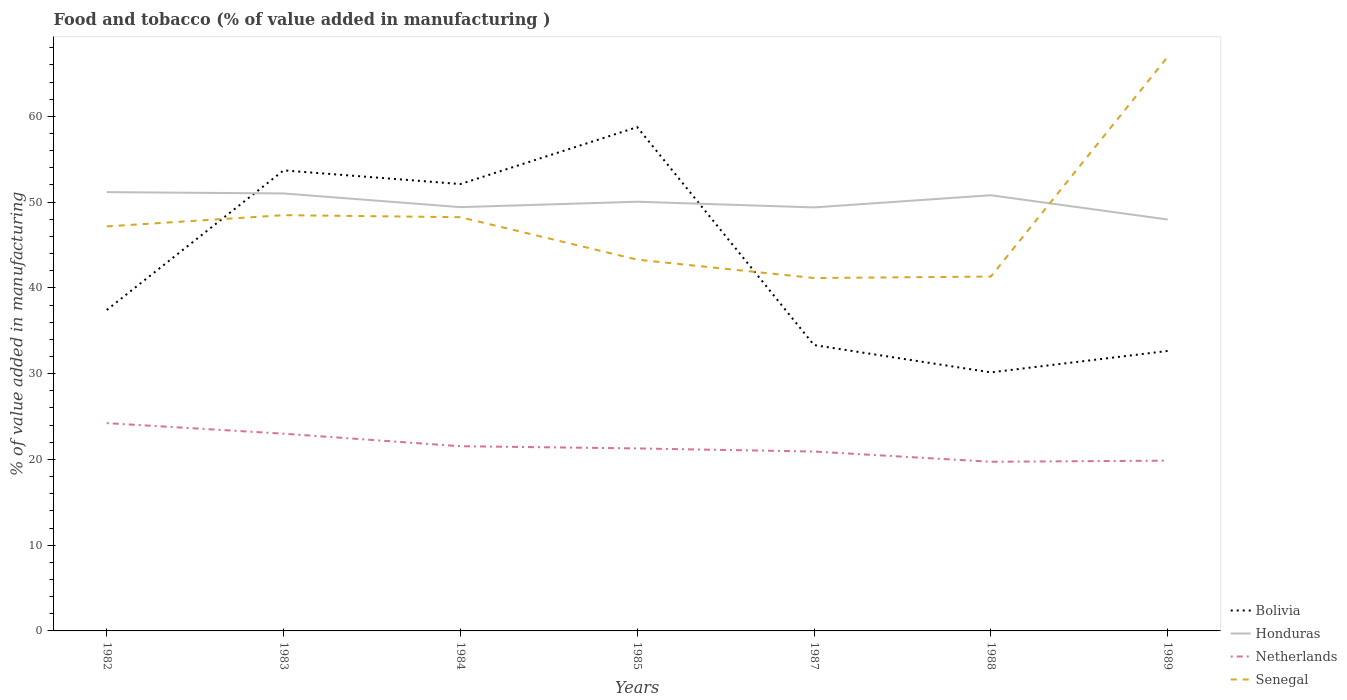How many different coloured lines are there?
Provide a short and direct response. 4. Is the number of lines equal to the number of legend labels?
Your response must be concise. Yes. Across all years, what is the maximum value added in manufacturing food and tobacco in Senegal?
Offer a very short reply. 41.15. In which year was the value added in manufacturing food and tobacco in Honduras maximum?
Your response must be concise. 1989. What is the total value added in manufacturing food and tobacco in Honduras in the graph?
Ensure brevity in your answer.  1.78. What is the difference between the highest and the second highest value added in manufacturing food and tobacco in Honduras?
Your response must be concise. 3.19. What is the difference between the highest and the lowest value added in manufacturing food and tobacco in Senegal?
Ensure brevity in your answer.  3. What is the difference between two consecutive major ticks on the Y-axis?
Your response must be concise. 10. What is the title of the graph?
Your answer should be compact. Food and tobacco (% of value added in manufacturing ). What is the label or title of the Y-axis?
Your response must be concise. % of value added in manufacturing. What is the % of value added in manufacturing in Bolivia in 1982?
Your response must be concise. 37.42. What is the % of value added in manufacturing of Honduras in 1982?
Your answer should be compact. 51.16. What is the % of value added in manufacturing in Netherlands in 1982?
Provide a short and direct response. 24.23. What is the % of value added in manufacturing of Senegal in 1982?
Make the answer very short. 47.17. What is the % of value added in manufacturing in Bolivia in 1983?
Offer a terse response. 53.7. What is the % of value added in manufacturing of Honduras in 1983?
Offer a very short reply. 51.01. What is the % of value added in manufacturing in Netherlands in 1983?
Make the answer very short. 23. What is the % of value added in manufacturing of Senegal in 1983?
Ensure brevity in your answer.  48.48. What is the % of value added in manufacturing of Bolivia in 1984?
Offer a terse response. 52.11. What is the % of value added in manufacturing of Honduras in 1984?
Make the answer very short. 49.41. What is the % of value added in manufacturing in Netherlands in 1984?
Give a very brief answer. 21.54. What is the % of value added in manufacturing of Senegal in 1984?
Your answer should be very brief. 48.24. What is the % of value added in manufacturing of Bolivia in 1985?
Ensure brevity in your answer.  58.75. What is the % of value added in manufacturing in Honduras in 1985?
Ensure brevity in your answer.  50.04. What is the % of value added in manufacturing in Netherlands in 1985?
Your answer should be compact. 21.28. What is the % of value added in manufacturing in Senegal in 1985?
Provide a succinct answer. 43.29. What is the % of value added in manufacturing in Bolivia in 1987?
Give a very brief answer. 33.33. What is the % of value added in manufacturing of Honduras in 1987?
Ensure brevity in your answer.  49.38. What is the % of value added in manufacturing in Netherlands in 1987?
Provide a short and direct response. 20.92. What is the % of value added in manufacturing in Senegal in 1987?
Your answer should be compact. 41.15. What is the % of value added in manufacturing of Bolivia in 1988?
Offer a very short reply. 30.15. What is the % of value added in manufacturing of Honduras in 1988?
Offer a terse response. 50.8. What is the % of value added in manufacturing in Netherlands in 1988?
Provide a short and direct response. 19.72. What is the % of value added in manufacturing in Senegal in 1988?
Provide a succinct answer. 41.32. What is the % of value added in manufacturing of Bolivia in 1989?
Offer a terse response. 32.65. What is the % of value added in manufacturing of Honduras in 1989?
Provide a succinct answer. 47.97. What is the % of value added in manufacturing in Netherlands in 1989?
Offer a very short reply. 19.86. What is the % of value added in manufacturing in Senegal in 1989?
Offer a terse response. 66.94. Across all years, what is the maximum % of value added in manufacturing in Bolivia?
Provide a succinct answer. 58.75. Across all years, what is the maximum % of value added in manufacturing of Honduras?
Your answer should be compact. 51.16. Across all years, what is the maximum % of value added in manufacturing of Netherlands?
Make the answer very short. 24.23. Across all years, what is the maximum % of value added in manufacturing in Senegal?
Your answer should be very brief. 66.94. Across all years, what is the minimum % of value added in manufacturing of Bolivia?
Offer a very short reply. 30.15. Across all years, what is the minimum % of value added in manufacturing in Honduras?
Ensure brevity in your answer.  47.97. Across all years, what is the minimum % of value added in manufacturing in Netherlands?
Provide a short and direct response. 19.72. Across all years, what is the minimum % of value added in manufacturing in Senegal?
Make the answer very short. 41.15. What is the total % of value added in manufacturing of Bolivia in the graph?
Your answer should be very brief. 298.1. What is the total % of value added in manufacturing in Honduras in the graph?
Your answer should be compact. 349.79. What is the total % of value added in manufacturing of Netherlands in the graph?
Your answer should be compact. 150.54. What is the total % of value added in manufacturing of Senegal in the graph?
Ensure brevity in your answer.  336.59. What is the difference between the % of value added in manufacturing of Bolivia in 1982 and that in 1983?
Make the answer very short. -16.28. What is the difference between the % of value added in manufacturing of Honduras in 1982 and that in 1983?
Your answer should be very brief. 0.15. What is the difference between the % of value added in manufacturing of Netherlands in 1982 and that in 1983?
Offer a very short reply. 1.23. What is the difference between the % of value added in manufacturing of Senegal in 1982 and that in 1983?
Your answer should be very brief. -1.31. What is the difference between the % of value added in manufacturing of Bolivia in 1982 and that in 1984?
Your answer should be very brief. -14.69. What is the difference between the % of value added in manufacturing in Honduras in 1982 and that in 1984?
Give a very brief answer. 1.75. What is the difference between the % of value added in manufacturing in Netherlands in 1982 and that in 1984?
Provide a short and direct response. 2.69. What is the difference between the % of value added in manufacturing in Senegal in 1982 and that in 1984?
Provide a succinct answer. -1.07. What is the difference between the % of value added in manufacturing of Bolivia in 1982 and that in 1985?
Offer a terse response. -21.32. What is the difference between the % of value added in manufacturing of Honduras in 1982 and that in 1985?
Your answer should be very brief. 1.12. What is the difference between the % of value added in manufacturing of Netherlands in 1982 and that in 1985?
Your response must be concise. 2.95. What is the difference between the % of value added in manufacturing in Senegal in 1982 and that in 1985?
Keep it short and to the point. 3.88. What is the difference between the % of value added in manufacturing of Bolivia in 1982 and that in 1987?
Make the answer very short. 4.09. What is the difference between the % of value added in manufacturing of Honduras in 1982 and that in 1987?
Ensure brevity in your answer.  1.78. What is the difference between the % of value added in manufacturing of Netherlands in 1982 and that in 1987?
Your response must be concise. 3.31. What is the difference between the % of value added in manufacturing of Senegal in 1982 and that in 1987?
Make the answer very short. 6.02. What is the difference between the % of value added in manufacturing in Bolivia in 1982 and that in 1988?
Offer a terse response. 7.28. What is the difference between the % of value added in manufacturing in Honduras in 1982 and that in 1988?
Your response must be concise. 0.36. What is the difference between the % of value added in manufacturing of Netherlands in 1982 and that in 1988?
Provide a succinct answer. 4.51. What is the difference between the % of value added in manufacturing in Senegal in 1982 and that in 1988?
Offer a very short reply. 5.85. What is the difference between the % of value added in manufacturing in Bolivia in 1982 and that in 1989?
Your answer should be compact. 4.78. What is the difference between the % of value added in manufacturing of Honduras in 1982 and that in 1989?
Your response must be concise. 3.19. What is the difference between the % of value added in manufacturing in Netherlands in 1982 and that in 1989?
Make the answer very short. 4.37. What is the difference between the % of value added in manufacturing of Senegal in 1982 and that in 1989?
Offer a very short reply. -19.77. What is the difference between the % of value added in manufacturing of Bolivia in 1983 and that in 1984?
Your answer should be compact. 1.59. What is the difference between the % of value added in manufacturing in Honduras in 1983 and that in 1984?
Provide a short and direct response. 1.6. What is the difference between the % of value added in manufacturing of Netherlands in 1983 and that in 1984?
Give a very brief answer. 1.46. What is the difference between the % of value added in manufacturing in Senegal in 1983 and that in 1984?
Your answer should be very brief. 0.24. What is the difference between the % of value added in manufacturing of Bolivia in 1983 and that in 1985?
Provide a short and direct response. -5.05. What is the difference between the % of value added in manufacturing in Honduras in 1983 and that in 1985?
Keep it short and to the point. 0.97. What is the difference between the % of value added in manufacturing of Netherlands in 1983 and that in 1985?
Keep it short and to the point. 1.72. What is the difference between the % of value added in manufacturing of Senegal in 1983 and that in 1985?
Offer a terse response. 5.19. What is the difference between the % of value added in manufacturing of Bolivia in 1983 and that in 1987?
Your response must be concise. 20.37. What is the difference between the % of value added in manufacturing in Honduras in 1983 and that in 1987?
Your response must be concise. 1.63. What is the difference between the % of value added in manufacturing of Netherlands in 1983 and that in 1987?
Offer a very short reply. 2.08. What is the difference between the % of value added in manufacturing in Senegal in 1983 and that in 1987?
Make the answer very short. 7.33. What is the difference between the % of value added in manufacturing of Bolivia in 1983 and that in 1988?
Your answer should be very brief. 23.55. What is the difference between the % of value added in manufacturing in Honduras in 1983 and that in 1988?
Make the answer very short. 0.21. What is the difference between the % of value added in manufacturing in Netherlands in 1983 and that in 1988?
Offer a very short reply. 3.27. What is the difference between the % of value added in manufacturing in Senegal in 1983 and that in 1988?
Your response must be concise. 7.16. What is the difference between the % of value added in manufacturing in Bolivia in 1983 and that in 1989?
Make the answer very short. 21.06. What is the difference between the % of value added in manufacturing in Honduras in 1983 and that in 1989?
Your answer should be very brief. 3.04. What is the difference between the % of value added in manufacturing of Netherlands in 1983 and that in 1989?
Offer a very short reply. 3.14. What is the difference between the % of value added in manufacturing in Senegal in 1983 and that in 1989?
Your answer should be very brief. -18.46. What is the difference between the % of value added in manufacturing of Bolivia in 1984 and that in 1985?
Provide a succinct answer. -6.64. What is the difference between the % of value added in manufacturing of Honduras in 1984 and that in 1985?
Keep it short and to the point. -0.63. What is the difference between the % of value added in manufacturing of Netherlands in 1984 and that in 1985?
Your response must be concise. 0.26. What is the difference between the % of value added in manufacturing in Senegal in 1984 and that in 1985?
Your response must be concise. 4.95. What is the difference between the % of value added in manufacturing in Bolivia in 1984 and that in 1987?
Offer a terse response. 18.78. What is the difference between the % of value added in manufacturing in Honduras in 1984 and that in 1987?
Make the answer very short. 0.03. What is the difference between the % of value added in manufacturing in Netherlands in 1984 and that in 1987?
Offer a very short reply. 0.62. What is the difference between the % of value added in manufacturing of Senegal in 1984 and that in 1987?
Provide a succinct answer. 7.09. What is the difference between the % of value added in manufacturing of Bolivia in 1984 and that in 1988?
Ensure brevity in your answer.  21.96. What is the difference between the % of value added in manufacturing in Honduras in 1984 and that in 1988?
Provide a succinct answer. -1.39. What is the difference between the % of value added in manufacturing of Netherlands in 1984 and that in 1988?
Offer a very short reply. 1.81. What is the difference between the % of value added in manufacturing in Senegal in 1984 and that in 1988?
Provide a succinct answer. 6.92. What is the difference between the % of value added in manufacturing of Bolivia in 1984 and that in 1989?
Ensure brevity in your answer.  19.46. What is the difference between the % of value added in manufacturing of Honduras in 1984 and that in 1989?
Offer a terse response. 1.44. What is the difference between the % of value added in manufacturing in Netherlands in 1984 and that in 1989?
Make the answer very short. 1.68. What is the difference between the % of value added in manufacturing in Senegal in 1984 and that in 1989?
Offer a terse response. -18.7. What is the difference between the % of value added in manufacturing in Bolivia in 1985 and that in 1987?
Give a very brief answer. 25.42. What is the difference between the % of value added in manufacturing of Honduras in 1985 and that in 1987?
Provide a succinct answer. 0.66. What is the difference between the % of value added in manufacturing in Netherlands in 1985 and that in 1987?
Offer a very short reply. 0.36. What is the difference between the % of value added in manufacturing in Senegal in 1985 and that in 1987?
Make the answer very short. 2.14. What is the difference between the % of value added in manufacturing in Bolivia in 1985 and that in 1988?
Provide a short and direct response. 28.6. What is the difference between the % of value added in manufacturing of Honduras in 1985 and that in 1988?
Provide a short and direct response. -0.76. What is the difference between the % of value added in manufacturing of Netherlands in 1985 and that in 1988?
Make the answer very short. 1.56. What is the difference between the % of value added in manufacturing in Senegal in 1985 and that in 1988?
Your answer should be very brief. 1.97. What is the difference between the % of value added in manufacturing in Bolivia in 1985 and that in 1989?
Your answer should be very brief. 26.1. What is the difference between the % of value added in manufacturing in Honduras in 1985 and that in 1989?
Offer a very short reply. 2.07. What is the difference between the % of value added in manufacturing in Netherlands in 1985 and that in 1989?
Keep it short and to the point. 1.42. What is the difference between the % of value added in manufacturing in Senegal in 1985 and that in 1989?
Provide a short and direct response. -23.65. What is the difference between the % of value added in manufacturing of Bolivia in 1987 and that in 1988?
Make the answer very short. 3.18. What is the difference between the % of value added in manufacturing in Honduras in 1987 and that in 1988?
Make the answer very short. -1.42. What is the difference between the % of value added in manufacturing of Netherlands in 1987 and that in 1988?
Provide a short and direct response. 1.19. What is the difference between the % of value added in manufacturing of Senegal in 1987 and that in 1988?
Keep it short and to the point. -0.17. What is the difference between the % of value added in manufacturing of Bolivia in 1987 and that in 1989?
Your answer should be compact. 0.68. What is the difference between the % of value added in manufacturing of Honduras in 1987 and that in 1989?
Your response must be concise. 1.41. What is the difference between the % of value added in manufacturing of Netherlands in 1987 and that in 1989?
Give a very brief answer. 1.06. What is the difference between the % of value added in manufacturing of Senegal in 1987 and that in 1989?
Give a very brief answer. -25.79. What is the difference between the % of value added in manufacturing of Bolivia in 1988 and that in 1989?
Your answer should be very brief. -2.5. What is the difference between the % of value added in manufacturing of Honduras in 1988 and that in 1989?
Make the answer very short. 2.83. What is the difference between the % of value added in manufacturing in Netherlands in 1988 and that in 1989?
Ensure brevity in your answer.  -0.13. What is the difference between the % of value added in manufacturing in Senegal in 1988 and that in 1989?
Make the answer very short. -25.62. What is the difference between the % of value added in manufacturing in Bolivia in 1982 and the % of value added in manufacturing in Honduras in 1983?
Provide a succinct answer. -13.59. What is the difference between the % of value added in manufacturing in Bolivia in 1982 and the % of value added in manufacturing in Netherlands in 1983?
Keep it short and to the point. 14.42. What is the difference between the % of value added in manufacturing of Bolivia in 1982 and the % of value added in manufacturing of Senegal in 1983?
Your response must be concise. -11.06. What is the difference between the % of value added in manufacturing in Honduras in 1982 and the % of value added in manufacturing in Netherlands in 1983?
Provide a succinct answer. 28.17. What is the difference between the % of value added in manufacturing in Honduras in 1982 and the % of value added in manufacturing in Senegal in 1983?
Your answer should be very brief. 2.69. What is the difference between the % of value added in manufacturing of Netherlands in 1982 and the % of value added in manufacturing of Senegal in 1983?
Your answer should be compact. -24.25. What is the difference between the % of value added in manufacturing in Bolivia in 1982 and the % of value added in manufacturing in Honduras in 1984?
Provide a short and direct response. -11.99. What is the difference between the % of value added in manufacturing in Bolivia in 1982 and the % of value added in manufacturing in Netherlands in 1984?
Offer a terse response. 15.88. What is the difference between the % of value added in manufacturing in Bolivia in 1982 and the % of value added in manufacturing in Senegal in 1984?
Offer a terse response. -10.82. What is the difference between the % of value added in manufacturing in Honduras in 1982 and the % of value added in manufacturing in Netherlands in 1984?
Provide a short and direct response. 29.63. What is the difference between the % of value added in manufacturing of Honduras in 1982 and the % of value added in manufacturing of Senegal in 1984?
Your answer should be very brief. 2.92. What is the difference between the % of value added in manufacturing in Netherlands in 1982 and the % of value added in manufacturing in Senegal in 1984?
Give a very brief answer. -24.01. What is the difference between the % of value added in manufacturing of Bolivia in 1982 and the % of value added in manufacturing of Honduras in 1985?
Your answer should be compact. -12.62. What is the difference between the % of value added in manufacturing of Bolivia in 1982 and the % of value added in manufacturing of Netherlands in 1985?
Your response must be concise. 16.14. What is the difference between the % of value added in manufacturing in Bolivia in 1982 and the % of value added in manufacturing in Senegal in 1985?
Your answer should be compact. -5.87. What is the difference between the % of value added in manufacturing in Honduras in 1982 and the % of value added in manufacturing in Netherlands in 1985?
Keep it short and to the point. 29.88. What is the difference between the % of value added in manufacturing in Honduras in 1982 and the % of value added in manufacturing in Senegal in 1985?
Keep it short and to the point. 7.87. What is the difference between the % of value added in manufacturing of Netherlands in 1982 and the % of value added in manufacturing of Senegal in 1985?
Offer a very short reply. -19.06. What is the difference between the % of value added in manufacturing in Bolivia in 1982 and the % of value added in manufacturing in Honduras in 1987?
Your answer should be very brief. -11.96. What is the difference between the % of value added in manufacturing of Bolivia in 1982 and the % of value added in manufacturing of Netherlands in 1987?
Keep it short and to the point. 16.5. What is the difference between the % of value added in manufacturing of Bolivia in 1982 and the % of value added in manufacturing of Senegal in 1987?
Provide a succinct answer. -3.73. What is the difference between the % of value added in manufacturing of Honduras in 1982 and the % of value added in manufacturing of Netherlands in 1987?
Your response must be concise. 30.25. What is the difference between the % of value added in manufacturing in Honduras in 1982 and the % of value added in manufacturing in Senegal in 1987?
Keep it short and to the point. 10.02. What is the difference between the % of value added in manufacturing in Netherlands in 1982 and the % of value added in manufacturing in Senegal in 1987?
Keep it short and to the point. -16.92. What is the difference between the % of value added in manufacturing in Bolivia in 1982 and the % of value added in manufacturing in Honduras in 1988?
Offer a terse response. -13.38. What is the difference between the % of value added in manufacturing in Bolivia in 1982 and the % of value added in manufacturing in Netherlands in 1988?
Provide a short and direct response. 17.7. What is the difference between the % of value added in manufacturing in Bolivia in 1982 and the % of value added in manufacturing in Senegal in 1988?
Your answer should be very brief. -3.9. What is the difference between the % of value added in manufacturing of Honduras in 1982 and the % of value added in manufacturing of Netherlands in 1988?
Ensure brevity in your answer.  31.44. What is the difference between the % of value added in manufacturing in Honduras in 1982 and the % of value added in manufacturing in Senegal in 1988?
Ensure brevity in your answer.  9.84. What is the difference between the % of value added in manufacturing of Netherlands in 1982 and the % of value added in manufacturing of Senegal in 1988?
Provide a short and direct response. -17.09. What is the difference between the % of value added in manufacturing in Bolivia in 1982 and the % of value added in manufacturing in Honduras in 1989?
Provide a short and direct response. -10.55. What is the difference between the % of value added in manufacturing of Bolivia in 1982 and the % of value added in manufacturing of Netherlands in 1989?
Offer a terse response. 17.57. What is the difference between the % of value added in manufacturing in Bolivia in 1982 and the % of value added in manufacturing in Senegal in 1989?
Keep it short and to the point. -29.52. What is the difference between the % of value added in manufacturing in Honduras in 1982 and the % of value added in manufacturing in Netherlands in 1989?
Your answer should be compact. 31.31. What is the difference between the % of value added in manufacturing of Honduras in 1982 and the % of value added in manufacturing of Senegal in 1989?
Ensure brevity in your answer.  -15.78. What is the difference between the % of value added in manufacturing in Netherlands in 1982 and the % of value added in manufacturing in Senegal in 1989?
Ensure brevity in your answer.  -42.71. What is the difference between the % of value added in manufacturing in Bolivia in 1983 and the % of value added in manufacturing in Honduras in 1984?
Offer a terse response. 4.29. What is the difference between the % of value added in manufacturing in Bolivia in 1983 and the % of value added in manufacturing in Netherlands in 1984?
Provide a short and direct response. 32.16. What is the difference between the % of value added in manufacturing of Bolivia in 1983 and the % of value added in manufacturing of Senegal in 1984?
Keep it short and to the point. 5.46. What is the difference between the % of value added in manufacturing in Honduras in 1983 and the % of value added in manufacturing in Netherlands in 1984?
Keep it short and to the point. 29.47. What is the difference between the % of value added in manufacturing in Honduras in 1983 and the % of value added in manufacturing in Senegal in 1984?
Your answer should be very brief. 2.77. What is the difference between the % of value added in manufacturing in Netherlands in 1983 and the % of value added in manufacturing in Senegal in 1984?
Offer a terse response. -25.24. What is the difference between the % of value added in manufacturing of Bolivia in 1983 and the % of value added in manufacturing of Honduras in 1985?
Your answer should be compact. 3.66. What is the difference between the % of value added in manufacturing of Bolivia in 1983 and the % of value added in manufacturing of Netherlands in 1985?
Offer a terse response. 32.42. What is the difference between the % of value added in manufacturing in Bolivia in 1983 and the % of value added in manufacturing in Senegal in 1985?
Provide a succinct answer. 10.41. What is the difference between the % of value added in manufacturing of Honduras in 1983 and the % of value added in manufacturing of Netherlands in 1985?
Make the answer very short. 29.73. What is the difference between the % of value added in manufacturing of Honduras in 1983 and the % of value added in manufacturing of Senegal in 1985?
Your answer should be very brief. 7.72. What is the difference between the % of value added in manufacturing of Netherlands in 1983 and the % of value added in manufacturing of Senegal in 1985?
Provide a short and direct response. -20.29. What is the difference between the % of value added in manufacturing of Bolivia in 1983 and the % of value added in manufacturing of Honduras in 1987?
Your answer should be very brief. 4.32. What is the difference between the % of value added in manufacturing of Bolivia in 1983 and the % of value added in manufacturing of Netherlands in 1987?
Provide a short and direct response. 32.78. What is the difference between the % of value added in manufacturing of Bolivia in 1983 and the % of value added in manufacturing of Senegal in 1987?
Keep it short and to the point. 12.55. What is the difference between the % of value added in manufacturing in Honduras in 1983 and the % of value added in manufacturing in Netherlands in 1987?
Ensure brevity in your answer.  30.09. What is the difference between the % of value added in manufacturing in Honduras in 1983 and the % of value added in manufacturing in Senegal in 1987?
Your answer should be compact. 9.86. What is the difference between the % of value added in manufacturing of Netherlands in 1983 and the % of value added in manufacturing of Senegal in 1987?
Your answer should be very brief. -18.15. What is the difference between the % of value added in manufacturing of Bolivia in 1983 and the % of value added in manufacturing of Honduras in 1988?
Your answer should be very brief. 2.9. What is the difference between the % of value added in manufacturing of Bolivia in 1983 and the % of value added in manufacturing of Netherlands in 1988?
Make the answer very short. 33.98. What is the difference between the % of value added in manufacturing of Bolivia in 1983 and the % of value added in manufacturing of Senegal in 1988?
Keep it short and to the point. 12.38. What is the difference between the % of value added in manufacturing of Honduras in 1983 and the % of value added in manufacturing of Netherlands in 1988?
Give a very brief answer. 31.29. What is the difference between the % of value added in manufacturing of Honduras in 1983 and the % of value added in manufacturing of Senegal in 1988?
Your answer should be very brief. 9.69. What is the difference between the % of value added in manufacturing of Netherlands in 1983 and the % of value added in manufacturing of Senegal in 1988?
Your answer should be very brief. -18.32. What is the difference between the % of value added in manufacturing in Bolivia in 1983 and the % of value added in manufacturing in Honduras in 1989?
Ensure brevity in your answer.  5.73. What is the difference between the % of value added in manufacturing of Bolivia in 1983 and the % of value added in manufacturing of Netherlands in 1989?
Offer a very short reply. 33.85. What is the difference between the % of value added in manufacturing in Bolivia in 1983 and the % of value added in manufacturing in Senegal in 1989?
Ensure brevity in your answer.  -13.24. What is the difference between the % of value added in manufacturing in Honduras in 1983 and the % of value added in manufacturing in Netherlands in 1989?
Offer a very short reply. 31.16. What is the difference between the % of value added in manufacturing in Honduras in 1983 and the % of value added in manufacturing in Senegal in 1989?
Offer a terse response. -15.93. What is the difference between the % of value added in manufacturing in Netherlands in 1983 and the % of value added in manufacturing in Senegal in 1989?
Ensure brevity in your answer.  -43.94. What is the difference between the % of value added in manufacturing of Bolivia in 1984 and the % of value added in manufacturing of Honduras in 1985?
Give a very brief answer. 2.06. What is the difference between the % of value added in manufacturing in Bolivia in 1984 and the % of value added in manufacturing in Netherlands in 1985?
Your answer should be compact. 30.83. What is the difference between the % of value added in manufacturing in Bolivia in 1984 and the % of value added in manufacturing in Senegal in 1985?
Provide a short and direct response. 8.82. What is the difference between the % of value added in manufacturing of Honduras in 1984 and the % of value added in manufacturing of Netherlands in 1985?
Provide a succinct answer. 28.13. What is the difference between the % of value added in manufacturing of Honduras in 1984 and the % of value added in manufacturing of Senegal in 1985?
Give a very brief answer. 6.12. What is the difference between the % of value added in manufacturing in Netherlands in 1984 and the % of value added in manufacturing in Senegal in 1985?
Provide a short and direct response. -21.75. What is the difference between the % of value added in manufacturing in Bolivia in 1984 and the % of value added in manufacturing in Honduras in 1987?
Ensure brevity in your answer.  2.72. What is the difference between the % of value added in manufacturing in Bolivia in 1984 and the % of value added in manufacturing in Netherlands in 1987?
Give a very brief answer. 31.19. What is the difference between the % of value added in manufacturing of Bolivia in 1984 and the % of value added in manufacturing of Senegal in 1987?
Your response must be concise. 10.96. What is the difference between the % of value added in manufacturing of Honduras in 1984 and the % of value added in manufacturing of Netherlands in 1987?
Your answer should be compact. 28.5. What is the difference between the % of value added in manufacturing of Honduras in 1984 and the % of value added in manufacturing of Senegal in 1987?
Your answer should be compact. 8.26. What is the difference between the % of value added in manufacturing in Netherlands in 1984 and the % of value added in manufacturing in Senegal in 1987?
Give a very brief answer. -19.61. What is the difference between the % of value added in manufacturing in Bolivia in 1984 and the % of value added in manufacturing in Honduras in 1988?
Make the answer very short. 1.31. What is the difference between the % of value added in manufacturing in Bolivia in 1984 and the % of value added in manufacturing in Netherlands in 1988?
Your response must be concise. 32.38. What is the difference between the % of value added in manufacturing of Bolivia in 1984 and the % of value added in manufacturing of Senegal in 1988?
Offer a very short reply. 10.79. What is the difference between the % of value added in manufacturing of Honduras in 1984 and the % of value added in manufacturing of Netherlands in 1988?
Your response must be concise. 29.69. What is the difference between the % of value added in manufacturing of Honduras in 1984 and the % of value added in manufacturing of Senegal in 1988?
Offer a terse response. 8.09. What is the difference between the % of value added in manufacturing of Netherlands in 1984 and the % of value added in manufacturing of Senegal in 1988?
Give a very brief answer. -19.78. What is the difference between the % of value added in manufacturing of Bolivia in 1984 and the % of value added in manufacturing of Honduras in 1989?
Give a very brief answer. 4.14. What is the difference between the % of value added in manufacturing in Bolivia in 1984 and the % of value added in manufacturing in Netherlands in 1989?
Provide a short and direct response. 32.25. What is the difference between the % of value added in manufacturing in Bolivia in 1984 and the % of value added in manufacturing in Senegal in 1989?
Provide a short and direct response. -14.83. What is the difference between the % of value added in manufacturing of Honduras in 1984 and the % of value added in manufacturing of Netherlands in 1989?
Your response must be concise. 29.56. What is the difference between the % of value added in manufacturing in Honduras in 1984 and the % of value added in manufacturing in Senegal in 1989?
Provide a succinct answer. -17.53. What is the difference between the % of value added in manufacturing of Netherlands in 1984 and the % of value added in manufacturing of Senegal in 1989?
Keep it short and to the point. -45.4. What is the difference between the % of value added in manufacturing in Bolivia in 1985 and the % of value added in manufacturing in Honduras in 1987?
Offer a terse response. 9.36. What is the difference between the % of value added in manufacturing in Bolivia in 1985 and the % of value added in manufacturing in Netherlands in 1987?
Provide a short and direct response. 37.83. What is the difference between the % of value added in manufacturing in Bolivia in 1985 and the % of value added in manufacturing in Senegal in 1987?
Provide a succinct answer. 17.6. What is the difference between the % of value added in manufacturing in Honduras in 1985 and the % of value added in manufacturing in Netherlands in 1987?
Provide a short and direct response. 29.13. What is the difference between the % of value added in manufacturing of Honduras in 1985 and the % of value added in manufacturing of Senegal in 1987?
Ensure brevity in your answer.  8.9. What is the difference between the % of value added in manufacturing of Netherlands in 1985 and the % of value added in manufacturing of Senegal in 1987?
Give a very brief answer. -19.87. What is the difference between the % of value added in manufacturing in Bolivia in 1985 and the % of value added in manufacturing in Honduras in 1988?
Offer a very short reply. 7.94. What is the difference between the % of value added in manufacturing in Bolivia in 1985 and the % of value added in manufacturing in Netherlands in 1988?
Your response must be concise. 39.02. What is the difference between the % of value added in manufacturing of Bolivia in 1985 and the % of value added in manufacturing of Senegal in 1988?
Your answer should be compact. 17.43. What is the difference between the % of value added in manufacturing of Honduras in 1985 and the % of value added in manufacturing of Netherlands in 1988?
Ensure brevity in your answer.  30.32. What is the difference between the % of value added in manufacturing in Honduras in 1985 and the % of value added in manufacturing in Senegal in 1988?
Provide a succinct answer. 8.72. What is the difference between the % of value added in manufacturing of Netherlands in 1985 and the % of value added in manufacturing of Senegal in 1988?
Your answer should be very brief. -20.04. What is the difference between the % of value added in manufacturing in Bolivia in 1985 and the % of value added in manufacturing in Honduras in 1989?
Make the answer very short. 10.77. What is the difference between the % of value added in manufacturing in Bolivia in 1985 and the % of value added in manufacturing in Netherlands in 1989?
Keep it short and to the point. 38.89. What is the difference between the % of value added in manufacturing in Bolivia in 1985 and the % of value added in manufacturing in Senegal in 1989?
Your response must be concise. -8.2. What is the difference between the % of value added in manufacturing in Honduras in 1985 and the % of value added in manufacturing in Netherlands in 1989?
Offer a terse response. 30.19. What is the difference between the % of value added in manufacturing of Honduras in 1985 and the % of value added in manufacturing of Senegal in 1989?
Your answer should be compact. -16.9. What is the difference between the % of value added in manufacturing of Netherlands in 1985 and the % of value added in manufacturing of Senegal in 1989?
Offer a terse response. -45.66. What is the difference between the % of value added in manufacturing in Bolivia in 1987 and the % of value added in manufacturing in Honduras in 1988?
Offer a very short reply. -17.47. What is the difference between the % of value added in manufacturing in Bolivia in 1987 and the % of value added in manufacturing in Netherlands in 1988?
Offer a very short reply. 13.61. What is the difference between the % of value added in manufacturing of Bolivia in 1987 and the % of value added in manufacturing of Senegal in 1988?
Offer a terse response. -7.99. What is the difference between the % of value added in manufacturing in Honduras in 1987 and the % of value added in manufacturing in Netherlands in 1988?
Ensure brevity in your answer.  29.66. What is the difference between the % of value added in manufacturing of Honduras in 1987 and the % of value added in manufacturing of Senegal in 1988?
Make the answer very short. 8.06. What is the difference between the % of value added in manufacturing of Netherlands in 1987 and the % of value added in manufacturing of Senegal in 1988?
Your answer should be very brief. -20.4. What is the difference between the % of value added in manufacturing in Bolivia in 1987 and the % of value added in manufacturing in Honduras in 1989?
Provide a succinct answer. -14.64. What is the difference between the % of value added in manufacturing in Bolivia in 1987 and the % of value added in manufacturing in Netherlands in 1989?
Your answer should be compact. 13.47. What is the difference between the % of value added in manufacturing of Bolivia in 1987 and the % of value added in manufacturing of Senegal in 1989?
Provide a short and direct response. -33.61. What is the difference between the % of value added in manufacturing in Honduras in 1987 and the % of value added in manufacturing in Netherlands in 1989?
Provide a short and direct response. 29.53. What is the difference between the % of value added in manufacturing in Honduras in 1987 and the % of value added in manufacturing in Senegal in 1989?
Provide a succinct answer. -17.56. What is the difference between the % of value added in manufacturing of Netherlands in 1987 and the % of value added in manufacturing of Senegal in 1989?
Give a very brief answer. -46.02. What is the difference between the % of value added in manufacturing of Bolivia in 1988 and the % of value added in manufacturing of Honduras in 1989?
Keep it short and to the point. -17.83. What is the difference between the % of value added in manufacturing of Bolivia in 1988 and the % of value added in manufacturing of Netherlands in 1989?
Your answer should be very brief. 10.29. What is the difference between the % of value added in manufacturing in Bolivia in 1988 and the % of value added in manufacturing in Senegal in 1989?
Provide a succinct answer. -36.8. What is the difference between the % of value added in manufacturing in Honduras in 1988 and the % of value added in manufacturing in Netherlands in 1989?
Your answer should be compact. 30.95. What is the difference between the % of value added in manufacturing of Honduras in 1988 and the % of value added in manufacturing of Senegal in 1989?
Keep it short and to the point. -16.14. What is the difference between the % of value added in manufacturing in Netherlands in 1988 and the % of value added in manufacturing in Senegal in 1989?
Offer a very short reply. -47.22. What is the average % of value added in manufacturing in Bolivia per year?
Provide a succinct answer. 42.59. What is the average % of value added in manufacturing of Honduras per year?
Your response must be concise. 49.97. What is the average % of value added in manufacturing in Netherlands per year?
Ensure brevity in your answer.  21.51. What is the average % of value added in manufacturing in Senegal per year?
Provide a succinct answer. 48.08. In the year 1982, what is the difference between the % of value added in manufacturing in Bolivia and % of value added in manufacturing in Honduras?
Make the answer very short. -13.74. In the year 1982, what is the difference between the % of value added in manufacturing in Bolivia and % of value added in manufacturing in Netherlands?
Offer a terse response. 13.19. In the year 1982, what is the difference between the % of value added in manufacturing in Bolivia and % of value added in manufacturing in Senegal?
Your response must be concise. -9.75. In the year 1982, what is the difference between the % of value added in manufacturing of Honduras and % of value added in manufacturing of Netherlands?
Offer a terse response. 26.93. In the year 1982, what is the difference between the % of value added in manufacturing of Honduras and % of value added in manufacturing of Senegal?
Your response must be concise. 4. In the year 1982, what is the difference between the % of value added in manufacturing of Netherlands and % of value added in manufacturing of Senegal?
Provide a short and direct response. -22.94. In the year 1983, what is the difference between the % of value added in manufacturing in Bolivia and % of value added in manufacturing in Honduras?
Your answer should be compact. 2.69. In the year 1983, what is the difference between the % of value added in manufacturing in Bolivia and % of value added in manufacturing in Netherlands?
Your response must be concise. 30.7. In the year 1983, what is the difference between the % of value added in manufacturing of Bolivia and % of value added in manufacturing of Senegal?
Offer a terse response. 5.22. In the year 1983, what is the difference between the % of value added in manufacturing in Honduras and % of value added in manufacturing in Netherlands?
Provide a short and direct response. 28.01. In the year 1983, what is the difference between the % of value added in manufacturing of Honduras and % of value added in manufacturing of Senegal?
Offer a terse response. 2.53. In the year 1983, what is the difference between the % of value added in manufacturing of Netherlands and % of value added in manufacturing of Senegal?
Your response must be concise. -25.48. In the year 1984, what is the difference between the % of value added in manufacturing in Bolivia and % of value added in manufacturing in Honduras?
Give a very brief answer. 2.69. In the year 1984, what is the difference between the % of value added in manufacturing of Bolivia and % of value added in manufacturing of Netherlands?
Make the answer very short. 30.57. In the year 1984, what is the difference between the % of value added in manufacturing of Bolivia and % of value added in manufacturing of Senegal?
Your answer should be compact. 3.87. In the year 1984, what is the difference between the % of value added in manufacturing of Honduras and % of value added in manufacturing of Netherlands?
Give a very brief answer. 27.88. In the year 1984, what is the difference between the % of value added in manufacturing in Honduras and % of value added in manufacturing in Senegal?
Provide a succinct answer. 1.17. In the year 1984, what is the difference between the % of value added in manufacturing in Netherlands and % of value added in manufacturing in Senegal?
Your response must be concise. -26.7. In the year 1985, what is the difference between the % of value added in manufacturing of Bolivia and % of value added in manufacturing of Honduras?
Your response must be concise. 8.7. In the year 1985, what is the difference between the % of value added in manufacturing of Bolivia and % of value added in manufacturing of Netherlands?
Offer a very short reply. 37.47. In the year 1985, what is the difference between the % of value added in manufacturing in Bolivia and % of value added in manufacturing in Senegal?
Offer a very short reply. 15.45. In the year 1985, what is the difference between the % of value added in manufacturing in Honduras and % of value added in manufacturing in Netherlands?
Your answer should be very brief. 28.76. In the year 1985, what is the difference between the % of value added in manufacturing in Honduras and % of value added in manufacturing in Senegal?
Your response must be concise. 6.75. In the year 1985, what is the difference between the % of value added in manufacturing in Netherlands and % of value added in manufacturing in Senegal?
Keep it short and to the point. -22.01. In the year 1987, what is the difference between the % of value added in manufacturing in Bolivia and % of value added in manufacturing in Honduras?
Offer a very short reply. -16.05. In the year 1987, what is the difference between the % of value added in manufacturing of Bolivia and % of value added in manufacturing of Netherlands?
Provide a succinct answer. 12.41. In the year 1987, what is the difference between the % of value added in manufacturing in Bolivia and % of value added in manufacturing in Senegal?
Ensure brevity in your answer.  -7.82. In the year 1987, what is the difference between the % of value added in manufacturing in Honduras and % of value added in manufacturing in Netherlands?
Offer a terse response. 28.47. In the year 1987, what is the difference between the % of value added in manufacturing in Honduras and % of value added in manufacturing in Senegal?
Provide a succinct answer. 8.23. In the year 1987, what is the difference between the % of value added in manufacturing of Netherlands and % of value added in manufacturing of Senegal?
Ensure brevity in your answer.  -20.23. In the year 1988, what is the difference between the % of value added in manufacturing in Bolivia and % of value added in manufacturing in Honduras?
Offer a very short reply. -20.66. In the year 1988, what is the difference between the % of value added in manufacturing in Bolivia and % of value added in manufacturing in Netherlands?
Your answer should be very brief. 10.42. In the year 1988, what is the difference between the % of value added in manufacturing of Bolivia and % of value added in manufacturing of Senegal?
Your answer should be very brief. -11.17. In the year 1988, what is the difference between the % of value added in manufacturing of Honduras and % of value added in manufacturing of Netherlands?
Offer a terse response. 31.08. In the year 1988, what is the difference between the % of value added in manufacturing in Honduras and % of value added in manufacturing in Senegal?
Your answer should be compact. 9.48. In the year 1988, what is the difference between the % of value added in manufacturing of Netherlands and % of value added in manufacturing of Senegal?
Offer a very short reply. -21.6. In the year 1989, what is the difference between the % of value added in manufacturing of Bolivia and % of value added in manufacturing of Honduras?
Provide a short and direct response. -15.33. In the year 1989, what is the difference between the % of value added in manufacturing in Bolivia and % of value added in manufacturing in Netherlands?
Offer a very short reply. 12.79. In the year 1989, what is the difference between the % of value added in manufacturing of Bolivia and % of value added in manufacturing of Senegal?
Make the answer very short. -34.3. In the year 1989, what is the difference between the % of value added in manufacturing of Honduras and % of value added in manufacturing of Netherlands?
Ensure brevity in your answer.  28.12. In the year 1989, what is the difference between the % of value added in manufacturing of Honduras and % of value added in manufacturing of Senegal?
Your answer should be very brief. -18.97. In the year 1989, what is the difference between the % of value added in manufacturing in Netherlands and % of value added in manufacturing in Senegal?
Your response must be concise. -47.09. What is the ratio of the % of value added in manufacturing of Bolivia in 1982 to that in 1983?
Provide a succinct answer. 0.7. What is the ratio of the % of value added in manufacturing of Honduras in 1982 to that in 1983?
Make the answer very short. 1. What is the ratio of the % of value added in manufacturing in Netherlands in 1982 to that in 1983?
Your response must be concise. 1.05. What is the ratio of the % of value added in manufacturing of Senegal in 1982 to that in 1983?
Ensure brevity in your answer.  0.97. What is the ratio of the % of value added in manufacturing of Bolivia in 1982 to that in 1984?
Make the answer very short. 0.72. What is the ratio of the % of value added in manufacturing of Honduras in 1982 to that in 1984?
Keep it short and to the point. 1.04. What is the ratio of the % of value added in manufacturing of Senegal in 1982 to that in 1984?
Give a very brief answer. 0.98. What is the ratio of the % of value added in manufacturing in Bolivia in 1982 to that in 1985?
Give a very brief answer. 0.64. What is the ratio of the % of value added in manufacturing of Honduras in 1982 to that in 1985?
Make the answer very short. 1.02. What is the ratio of the % of value added in manufacturing in Netherlands in 1982 to that in 1985?
Make the answer very short. 1.14. What is the ratio of the % of value added in manufacturing in Senegal in 1982 to that in 1985?
Provide a succinct answer. 1.09. What is the ratio of the % of value added in manufacturing of Bolivia in 1982 to that in 1987?
Keep it short and to the point. 1.12. What is the ratio of the % of value added in manufacturing of Honduras in 1982 to that in 1987?
Give a very brief answer. 1.04. What is the ratio of the % of value added in manufacturing in Netherlands in 1982 to that in 1987?
Provide a succinct answer. 1.16. What is the ratio of the % of value added in manufacturing of Senegal in 1982 to that in 1987?
Your answer should be very brief. 1.15. What is the ratio of the % of value added in manufacturing in Bolivia in 1982 to that in 1988?
Your answer should be very brief. 1.24. What is the ratio of the % of value added in manufacturing of Honduras in 1982 to that in 1988?
Offer a very short reply. 1.01. What is the ratio of the % of value added in manufacturing of Netherlands in 1982 to that in 1988?
Give a very brief answer. 1.23. What is the ratio of the % of value added in manufacturing in Senegal in 1982 to that in 1988?
Your answer should be very brief. 1.14. What is the ratio of the % of value added in manufacturing in Bolivia in 1982 to that in 1989?
Provide a short and direct response. 1.15. What is the ratio of the % of value added in manufacturing in Honduras in 1982 to that in 1989?
Your answer should be compact. 1.07. What is the ratio of the % of value added in manufacturing in Netherlands in 1982 to that in 1989?
Your answer should be very brief. 1.22. What is the ratio of the % of value added in manufacturing in Senegal in 1982 to that in 1989?
Ensure brevity in your answer.  0.7. What is the ratio of the % of value added in manufacturing of Bolivia in 1983 to that in 1984?
Offer a very short reply. 1.03. What is the ratio of the % of value added in manufacturing in Honduras in 1983 to that in 1984?
Offer a very short reply. 1.03. What is the ratio of the % of value added in manufacturing in Netherlands in 1983 to that in 1984?
Offer a very short reply. 1.07. What is the ratio of the % of value added in manufacturing of Bolivia in 1983 to that in 1985?
Your response must be concise. 0.91. What is the ratio of the % of value added in manufacturing in Honduras in 1983 to that in 1985?
Provide a short and direct response. 1.02. What is the ratio of the % of value added in manufacturing in Netherlands in 1983 to that in 1985?
Offer a terse response. 1.08. What is the ratio of the % of value added in manufacturing in Senegal in 1983 to that in 1985?
Offer a very short reply. 1.12. What is the ratio of the % of value added in manufacturing in Bolivia in 1983 to that in 1987?
Keep it short and to the point. 1.61. What is the ratio of the % of value added in manufacturing of Honduras in 1983 to that in 1987?
Keep it short and to the point. 1.03. What is the ratio of the % of value added in manufacturing of Netherlands in 1983 to that in 1987?
Your response must be concise. 1.1. What is the ratio of the % of value added in manufacturing of Senegal in 1983 to that in 1987?
Offer a very short reply. 1.18. What is the ratio of the % of value added in manufacturing in Bolivia in 1983 to that in 1988?
Make the answer very short. 1.78. What is the ratio of the % of value added in manufacturing of Honduras in 1983 to that in 1988?
Make the answer very short. 1. What is the ratio of the % of value added in manufacturing of Netherlands in 1983 to that in 1988?
Give a very brief answer. 1.17. What is the ratio of the % of value added in manufacturing in Senegal in 1983 to that in 1988?
Your answer should be compact. 1.17. What is the ratio of the % of value added in manufacturing of Bolivia in 1983 to that in 1989?
Your answer should be compact. 1.65. What is the ratio of the % of value added in manufacturing of Honduras in 1983 to that in 1989?
Make the answer very short. 1.06. What is the ratio of the % of value added in manufacturing in Netherlands in 1983 to that in 1989?
Provide a short and direct response. 1.16. What is the ratio of the % of value added in manufacturing in Senegal in 1983 to that in 1989?
Provide a succinct answer. 0.72. What is the ratio of the % of value added in manufacturing of Bolivia in 1984 to that in 1985?
Your response must be concise. 0.89. What is the ratio of the % of value added in manufacturing in Honduras in 1984 to that in 1985?
Provide a succinct answer. 0.99. What is the ratio of the % of value added in manufacturing of Netherlands in 1984 to that in 1985?
Make the answer very short. 1.01. What is the ratio of the % of value added in manufacturing in Senegal in 1984 to that in 1985?
Ensure brevity in your answer.  1.11. What is the ratio of the % of value added in manufacturing of Bolivia in 1984 to that in 1987?
Offer a very short reply. 1.56. What is the ratio of the % of value added in manufacturing of Netherlands in 1984 to that in 1987?
Offer a very short reply. 1.03. What is the ratio of the % of value added in manufacturing of Senegal in 1984 to that in 1987?
Keep it short and to the point. 1.17. What is the ratio of the % of value added in manufacturing of Bolivia in 1984 to that in 1988?
Give a very brief answer. 1.73. What is the ratio of the % of value added in manufacturing in Honduras in 1984 to that in 1988?
Offer a terse response. 0.97. What is the ratio of the % of value added in manufacturing in Netherlands in 1984 to that in 1988?
Offer a terse response. 1.09. What is the ratio of the % of value added in manufacturing of Senegal in 1984 to that in 1988?
Make the answer very short. 1.17. What is the ratio of the % of value added in manufacturing of Bolivia in 1984 to that in 1989?
Keep it short and to the point. 1.6. What is the ratio of the % of value added in manufacturing in Honduras in 1984 to that in 1989?
Make the answer very short. 1.03. What is the ratio of the % of value added in manufacturing in Netherlands in 1984 to that in 1989?
Your answer should be compact. 1.08. What is the ratio of the % of value added in manufacturing of Senegal in 1984 to that in 1989?
Keep it short and to the point. 0.72. What is the ratio of the % of value added in manufacturing of Bolivia in 1985 to that in 1987?
Your answer should be very brief. 1.76. What is the ratio of the % of value added in manufacturing in Honduras in 1985 to that in 1987?
Offer a very short reply. 1.01. What is the ratio of the % of value added in manufacturing in Netherlands in 1985 to that in 1987?
Provide a short and direct response. 1.02. What is the ratio of the % of value added in manufacturing in Senegal in 1985 to that in 1987?
Your answer should be compact. 1.05. What is the ratio of the % of value added in manufacturing of Bolivia in 1985 to that in 1988?
Offer a very short reply. 1.95. What is the ratio of the % of value added in manufacturing of Honduras in 1985 to that in 1988?
Offer a terse response. 0.99. What is the ratio of the % of value added in manufacturing in Netherlands in 1985 to that in 1988?
Your answer should be very brief. 1.08. What is the ratio of the % of value added in manufacturing of Senegal in 1985 to that in 1988?
Give a very brief answer. 1.05. What is the ratio of the % of value added in manufacturing of Bolivia in 1985 to that in 1989?
Your response must be concise. 1.8. What is the ratio of the % of value added in manufacturing of Honduras in 1985 to that in 1989?
Ensure brevity in your answer.  1.04. What is the ratio of the % of value added in manufacturing of Netherlands in 1985 to that in 1989?
Offer a very short reply. 1.07. What is the ratio of the % of value added in manufacturing of Senegal in 1985 to that in 1989?
Keep it short and to the point. 0.65. What is the ratio of the % of value added in manufacturing in Bolivia in 1987 to that in 1988?
Ensure brevity in your answer.  1.11. What is the ratio of the % of value added in manufacturing of Honduras in 1987 to that in 1988?
Ensure brevity in your answer.  0.97. What is the ratio of the % of value added in manufacturing in Netherlands in 1987 to that in 1988?
Give a very brief answer. 1.06. What is the ratio of the % of value added in manufacturing of Bolivia in 1987 to that in 1989?
Your response must be concise. 1.02. What is the ratio of the % of value added in manufacturing of Honduras in 1987 to that in 1989?
Your answer should be compact. 1.03. What is the ratio of the % of value added in manufacturing of Netherlands in 1987 to that in 1989?
Your answer should be compact. 1.05. What is the ratio of the % of value added in manufacturing in Senegal in 1987 to that in 1989?
Your response must be concise. 0.61. What is the ratio of the % of value added in manufacturing in Bolivia in 1988 to that in 1989?
Keep it short and to the point. 0.92. What is the ratio of the % of value added in manufacturing of Honduras in 1988 to that in 1989?
Offer a very short reply. 1.06. What is the ratio of the % of value added in manufacturing of Senegal in 1988 to that in 1989?
Provide a succinct answer. 0.62. What is the difference between the highest and the second highest % of value added in manufacturing of Bolivia?
Your answer should be very brief. 5.05. What is the difference between the highest and the second highest % of value added in manufacturing in Honduras?
Keep it short and to the point. 0.15. What is the difference between the highest and the second highest % of value added in manufacturing in Netherlands?
Your answer should be compact. 1.23. What is the difference between the highest and the second highest % of value added in manufacturing of Senegal?
Your answer should be compact. 18.46. What is the difference between the highest and the lowest % of value added in manufacturing in Bolivia?
Offer a terse response. 28.6. What is the difference between the highest and the lowest % of value added in manufacturing of Honduras?
Ensure brevity in your answer.  3.19. What is the difference between the highest and the lowest % of value added in manufacturing in Netherlands?
Offer a very short reply. 4.51. What is the difference between the highest and the lowest % of value added in manufacturing of Senegal?
Your response must be concise. 25.79. 